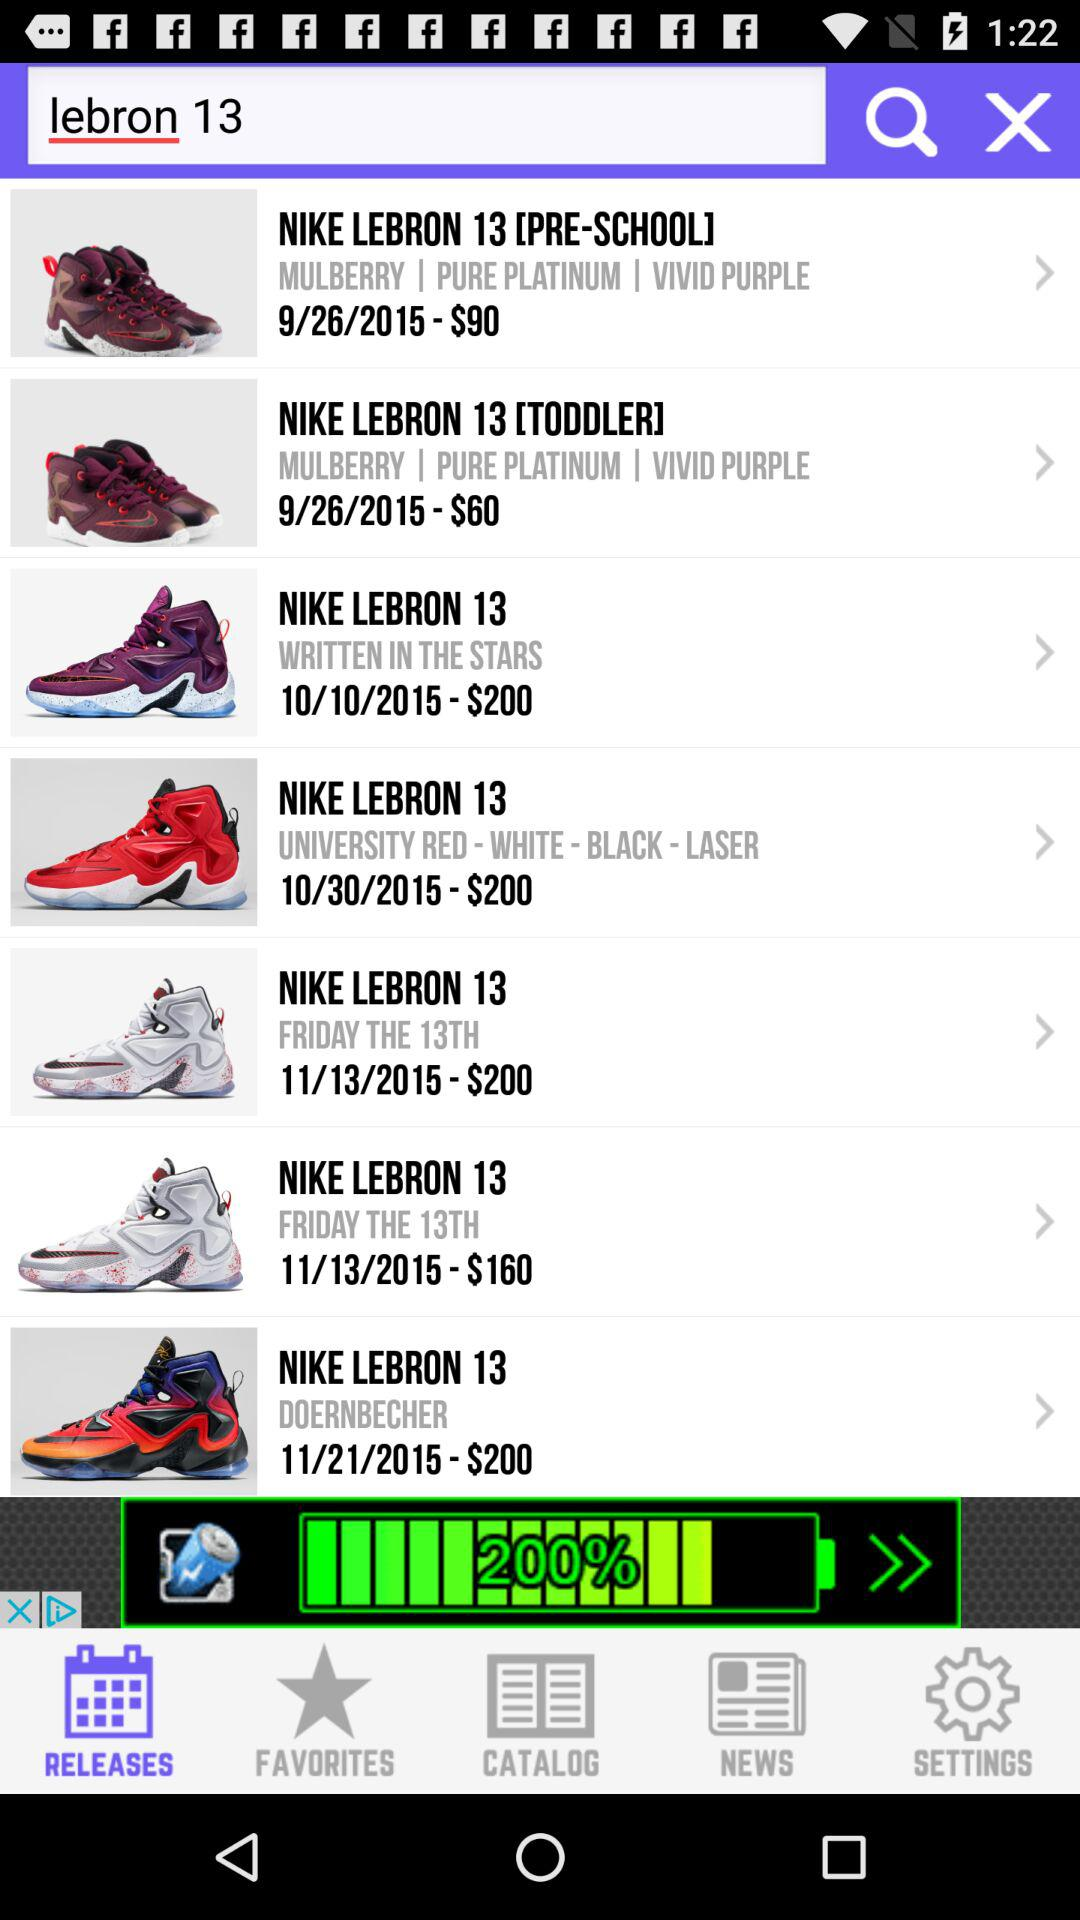What is the price of "NIKE LEBRON 13 DOERNBECHER"? The price of "NIKE LEBRON 13 DOERNBECHER" is $200. 